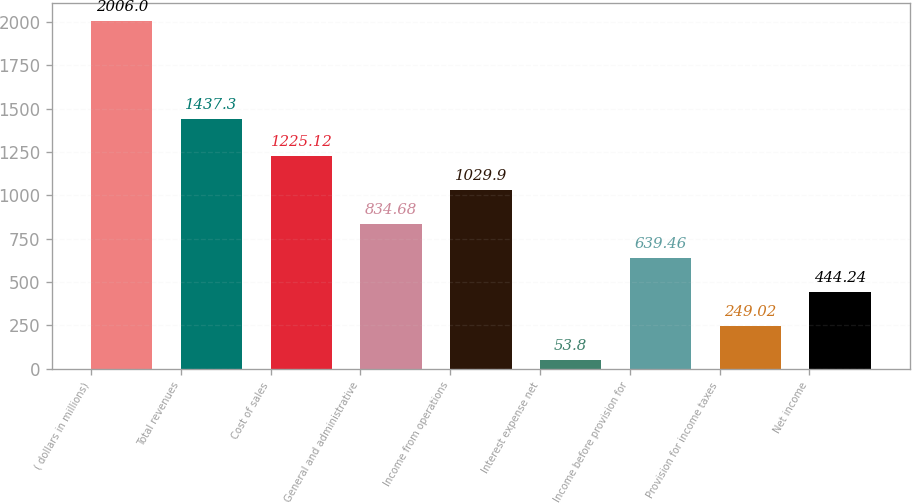Convert chart. <chart><loc_0><loc_0><loc_500><loc_500><bar_chart><fcel>( dollars in millions)<fcel>Total revenues<fcel>Cost of sales<fcel>General and administrative<fcel>Income from operations<fcel>Interest expense net<fcel>Income before provision for<fcel>Provision for income taxes<fcel>Net income<nl><fcel>2006<fcel>1437.3<fcel>1225.12<fcel>834.68<fcel>1029.9<fcel>53.8<fcel>639.46<fcel>249.02<fcel>444.24<nl></chart> 